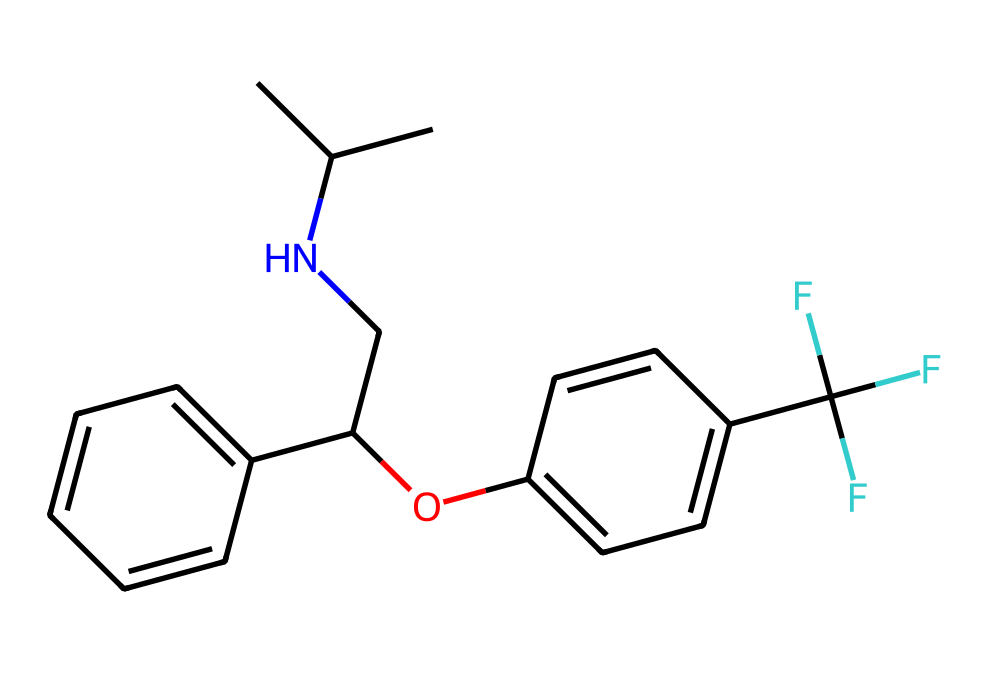What is the total number of carbon atoms in fluoxetine? By analyzing the provided SMILES representation, I count all the 'C' atoms present, considering branches and substituents. In this case, there are 16 carbon atoms in the structure.
Answer: 16 How many nitrogen atoms are present in fluoxetine? In the SMILES structure, each 'N' represents a nitrogen atom. Upon reviewing the chemical, there is only one nitrogen atom present in fluoxetine.
Answer: 1 Which functional group is suggested by the presence of the 'O' in the structure? The oxygen atom (O) in the structure is a key indicator of an ether functional group, as it is connected to two carbon atoms, resulting in the 'Oc' part of the compound.
Answer: ether What type of bonding is primarily responsible for the interactions in fluoxetine? Fluoxetine, being an antidepressant, primarily relies on hydrogen bonding due to the presence of -OH (hydroxyl) groups and the nitrogen atom capable of forming hydrogen bonds. This interaction is crucial for its biological activity.
Answer: hydrogen bonding Explain the significance of the trifluoromethyl group (C(F)(F)F). The trifluoromethyl group (C(F)(F)F) contributes to the lipophilicity and metabolic stability of fluoxetine, allowing better targeting of serotonin transporters and reducing metabolism, providing enhanced pharmacological action.
Answer: lipophilicity What type of drug class does fluoxetine belong to? Based on its chemical structure, fluoxetine is designated as a selective serotonin reuptake inhibitor (SSRI), which is a class of drugs commonly used to treat depression and anxiety by increasing serotonin levels in the brain.
Answer: SSRI 